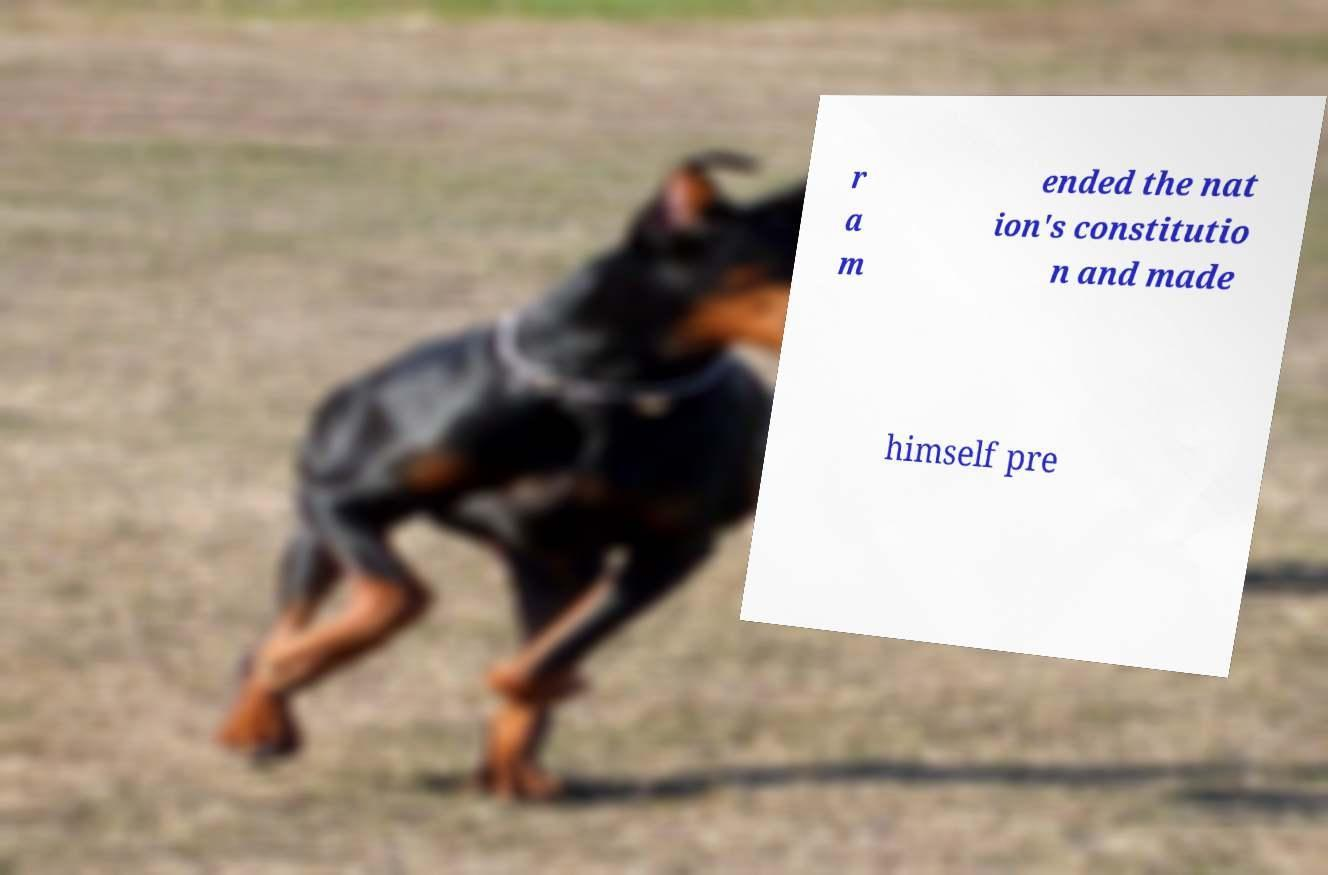Could you extract and type out the text from this image? r a m ended the nat ion's constitutio n and made himself pre 